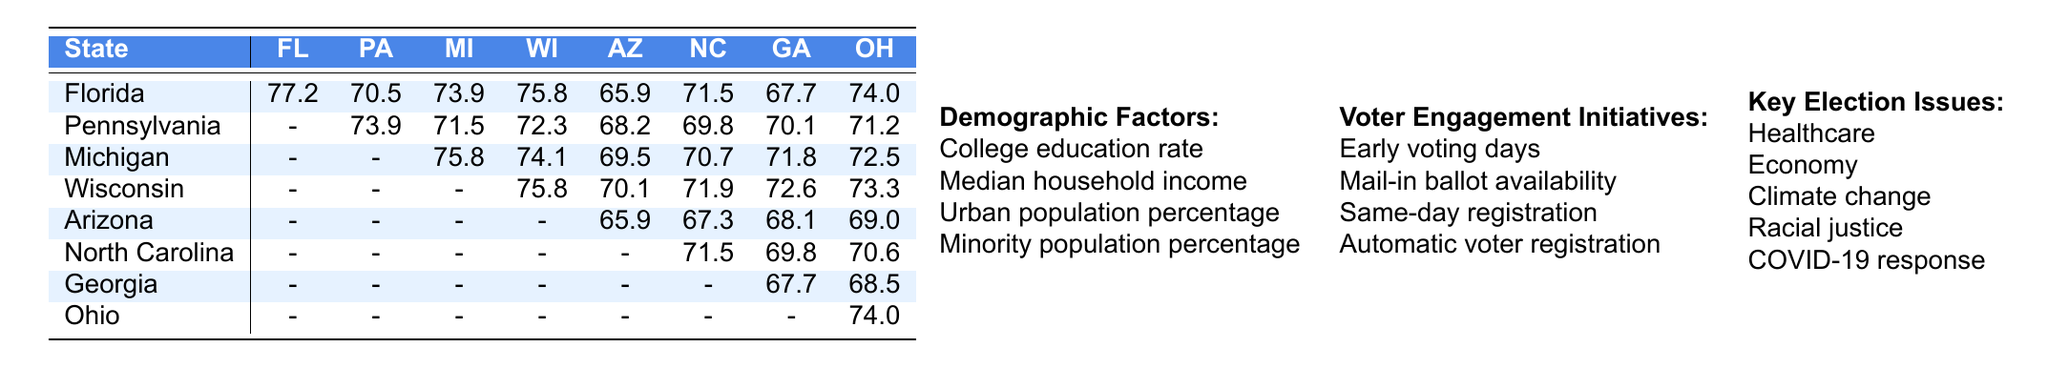What was the voter turnout rate in Florida? The table shows the voter turnout rate for Florida, which is listed as 77.2.
Answer: 77.2 Which state had the highest voter turnout rate? By examining the turnout rates in the table, Florida has the highest rate at 77.2, compared to Pennsylvania's 73.9 and others which are lower.
Answer: Florida What is the average voter turnout rate for Pennsylvania and Wisconsin? Pennsylvania's turnout rate is 73.9, and Wisconsin's is 75.8. To find the average, add them together (73.9 + 75.8 = 149.7) and divide by 2, getting 74.85.
Answer: 74.85 Is the voter turnout rate in Arizona lower than that in Georgia? Arizona’s turnout rate is 65.9, while Georgia's is 67.7. Since 65.9 is less than 67.7, the statement is true.
Answer: Yes What is the difference in voter turnout rates between Michigan and North Carolina? The turnout rate for Michigan is 75.8 and for North Carolina is 71.5. Finding the difference means subtracting North Carolina’s rate from Michigan's (75.8 - 71.5 = 4.3).
Answer: 4.3 Which state has the lowest turnout rate based on the data? Analyzing the turnout rates across all states, Arizona has the lowest at 65.9.
Answer: Arizona How does the voter turnout in Georgia compare to that in Pennsylvania? Georgia’s rate is 67.7, while Pennsylvania’s is 73.9. Comparing them shows that Georgia has a lower turnout rate at 67.7.
Answer: Lower Calculate the average voter turnout rate for Florida, Pennsylvania, and Michigan. The rates for these states are 77.2, 73.9, and 75.8, respectively. First, sum them up: (77.2 + 73.9 + 75.8 = 226.9), and then divide by 3: (226.9 / 3 = 75.63).
Answer: 75.63 Which demographic factor could potentially influence the turnout rates the most? The table lists 'Collegiate education rate', which often correlates with voter turnout. Higher education rates typically lead to greater engagement in elections, suggesting it may have a significant impact.
Answer: College education rate If North Carolina scored 71.5, how much did it fall short compared to the top-performing state? The top state, Florida, has a turnout rate of 77.2. To find how much North Carolina falls short, subtract North Carolina’s rate from Florida’s (77.2 - 71.5 = 5.7).
Answer: 5.7 